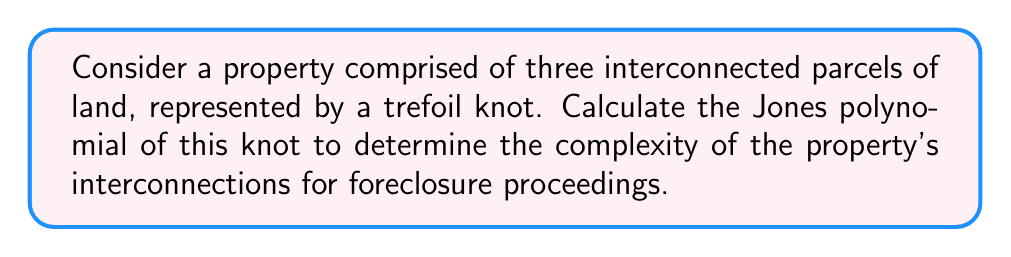Can you solve this math problem? To calculate the Jones polynomial of a trefoil knot representing interconnected parcels of land:

1. Start with the skein relation for the Jones polynomial:
   $$t^{-1}V(L_+) - tV(L_-) = (t^{1/2} - t^{-1/2})V(L_0)$$

2. For a trefoil knot, we need to apply this relation three times:

   [asy]
   import geometry;

   size(100);
   draw((-1,-1)--(1,1), arrow=Arrow());
   draw((1,-1)--(-1,1), arrow=Arrow());
   draw((-0.5,-0.5)--(0.5,-0.5), arrow=Arrow());
   [/asy]

3. First crossing:
   $$V(L_+) = tV(L_-) + t^{1/2}(t^{1/2} - t^{-1/2})V(L_0)$$
   Where $L_-$ is a figure-8 knot and $L_0$ is an unknot.

4. For the figure-8 knot:
   $$V(L_-) = t^{-1}V(L_+) + t^{-1/2}(t^{1/2} - t^{-1/2})V(L_0)$$
   Where $L_+$ is a trefoil and $L_0$ is an unknot.

5. Substitute and simplify:
   $$V(\text{trefoil}) = t \cdot t^{-1}V(\text{trefoil}) + t \cdot t^{-1/2}(t^{1/2} - t^{-1/2})V(\text{unknot}) + t^{1/2}(t^{1/2} - t^{-1/2})V(\text{unknot})$$

6. The Jones polynomial of an unknot is 1, so:
   $$V(\text{trefoil}) = V(\text{trefoil}) + t(t^{1/2} - t^{-1/2}) + t^{1/2}(t^{1/2} - t^{-1/2})$$

7. Solve for $V(\text{trefoil})$:
   $$0 = t(t^{1/2} - t^{-1/2}) + t^{1/2}(t^{1/2} - t^{-1/2})$$
   $$V(\text{trefoil}) = t(t^{1/2} - t^{-1/2}) + t^{1/2}(t^{1/2} - t^{-1/2})$$

8. Simplify:
   $$V(\text{trefoil}) = t^{3/2} - t^{1/2} + t - t^{-1}$$

This Jones polynomial represents the complexity of the interconnections between the three parcels of land, which can be useful in foreclosure proceedings to understand the property's structure.
Answer: $t^{3/2} - t^{1/2} + t - t^{-1}$ 